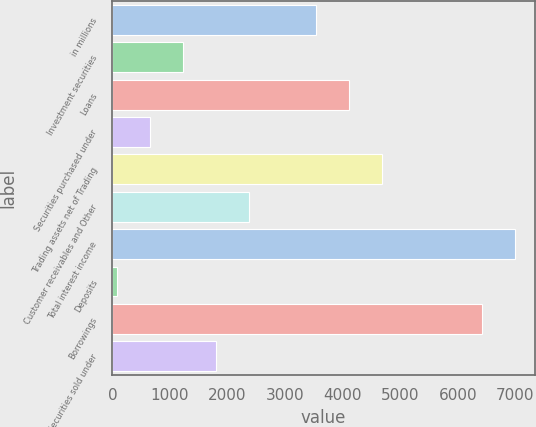Convert chart. <chart><loc_0><loc_0><loc_500><loc_500><bar_chart><fcel>in millions<fcel>Investment securities<fcel>Loans<fcel>Securities purchased under<fcel>Trading assets net of Trading<fcel>Customer receivables and Other<fcel>Total interest income<fcel>Deposits<fcel>Borrowings<fcel>Securities sold under<nl><fcel>3532.2<fcel>1229.4<fcel>4107.9<fcel>653.7<fcel>4683.6<fcel>2380.8<fcel>6986.4<fcel>78<fcel>6410.7<fcel>1805.1<nl></chart> 